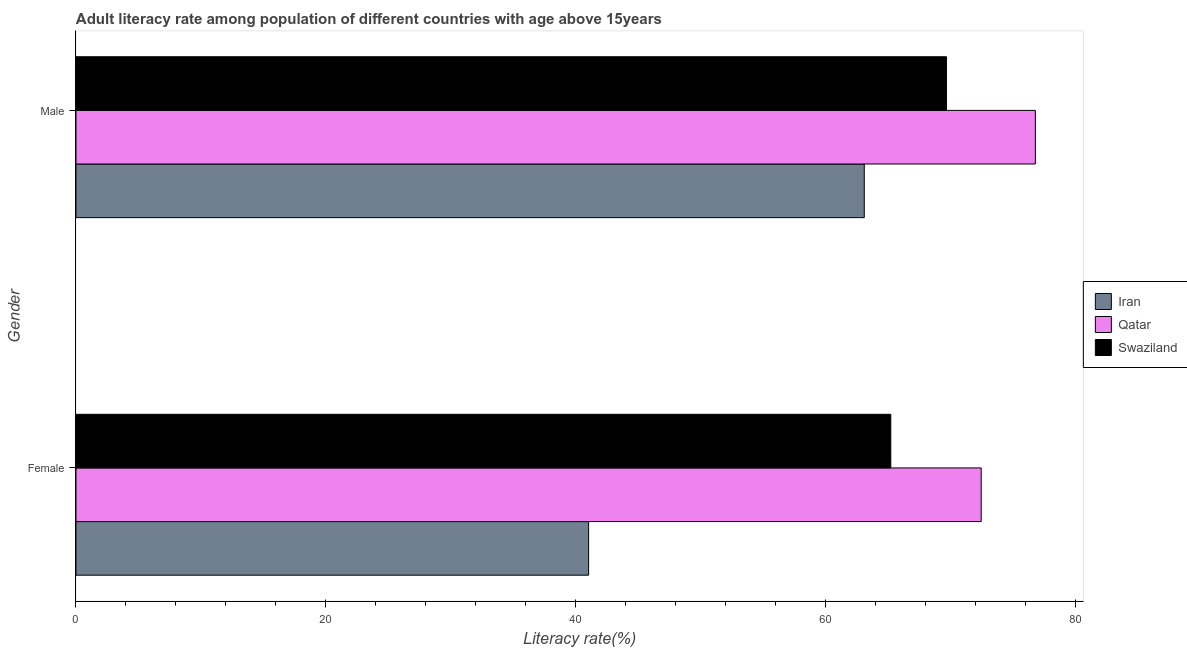How many bars are there on the 2nd tick from the top?
Make the answer very short. 3. What is the label of the 1st group of bars from the top?
Provide a succinct answer. Male. What is the female adult literacy rate in Qatar?
Offer a very short reply. 72.46. Across all countries, what is the maximum female adult literacy rate?
Your response must be concise. 72.46. Across all countries, what is the minimum male adult literacy rate?
Offer a terse response. 63.1. In which country was the female adult literacy rate maximum?
Your response must be concise. Qatar. In which country was the female adult literacy rate minimum?
Your answer should be very brief. Iran. What is the total male adult literacy rate in the graph?
Offer a very short reply. 209.58. What is the difference between the female adult literacy rate in Qatar and that in Iran?
Give a very brief answer. 31.43. What is the difference between the female adult literacy rate in Swaziland and the male adult literacy rate in Iran?
Give a very brief answer. 2.12. What is the average male adult literacy rate per country?
Offer a terse response. 69.86. What is the difference between the female adult literacy rate and male adult literacy rate in Iran?
Ensure brevity in your answer.  -22.07. In how many countries, is the male adult literacy rate greater than 60 %?
Keep it short and to the point. 3. What is the ratio of the female adult literacy rate in Iran to that in Swaziland?
Your answer should be very brief. 0.63. What does the 2nd bar from the top in Female represents?
Offer a very short reply. Qatar. What does the 2nd bar from the bottom in Female represents?
Your answer should be compact. Qatar. How many bars are there?
Your answer should be very brief. 6. Does the graph contain any zero values?
Provide a succinct answer. No. How are the legend labels stacked?
Make the answer very short. Vertical. What is the title of the graph?
Make the answer very short. Adult literacy rate among population of different countries with age above 15years. Does "Equatorial Guinea" appear as one of the legend labels in the graph?
Your answer should be compact. No. What is the label or title of the X-axis?
Offer a terse response. Literacy rate(%). What is the Literacy rate(%) of Iran in Female?
Offer a very short reply. 41.03. What is the Literacy rate(%) of Qatar in Female?
Your answer should be very brief. 72.46. What is the Literacy rate(%) of Swaziland in Female?
Offer a terse response. 65.22. What is the Literacy rate(%) of Iran in Male?
Give a very brief answer. 63.1. What is the Literacy rate(%) in Qatar in Male?
Make the answer very short. 76.8. What is the Literacy rate(%) of Swaziland in Male?
Give a very brief answer. 69.68. Across all Gender, what is the maximum Literacy rate(%) of Iran?
Ensure brevity in your answer.  63.1. Across all Gender, what is the maximum Literacy rate(%) in Qatar?
Your answer should be very brief. 76.8. Across all Gender, what is the maximum Literacy rate(%) in Swaziland?
Make the answer very short. 69.68. Across all Gender, what is the minimum Literacy rate(%) in Iran?
Provide a succinct answer. 41.03. Across all Gender, what is the minimum Literacy rate(%) of Qatar?
Ensure brevity in your answer.  72.46. Across all Gender, what is the minimum Literacy rate(%) of Swaziland?
Make the answer very short. 65.22. What is the total Literacy rate(%) of Iran in the graph?
Offer a very short reply. 104.13. What is the total Literacy rate(%) of Qatar in the graph?
Make the answer very short. 149.25. What is the total Literacy rate(%) of Swaziland in the graph?
Your response must be concise. 134.91. What is the difference between the Literacy rate(%) in Iran in Female and that in Male?
Ensure brevity in your answer.  -22.07. What is the difference between the Literacy rate(%) of Qatar in Female and that in Male?
Offer a very short reply. -4.34. What is the difference between the Literacy rate(%) of Swaziland in Female and that in Male?
Provide a short and direct response. -4.46. What is the difference between the Literacy rate(%) in Iran in Female and the Literacy rate(%) in Qatar in Male?
Offer a terse response. -35.76. What is the difference between the Literacy rate(%) of Iran in Female and the Literacy rate(%) of Swaziland in Male?
Keep it short and to the point. -28.65. What is the difference between the Literacy rate(%) in Qatar in Female and the Literacy rate(%) in Swaziland in Male?
Give a very brief answer. 2.78. What is the average Literacy rate(%) in Iran per Gender?
Give a very brief answer. 52.07. What is the average Literacy rate(%) of Qatar per Gender?
Give a very brief answer. 74.63. What is the average Literacy rate(%) in Swaziland per Gender?
Your response must be concise. 67.45. What is the difference between the Literacy rate(%) in Iran and Literacy rate(%) in Qatar in Female?
Your answer should be very brief. -31.43. What is the difference between the Literacy rate(%) in Iran and Literacy rate(%) in Swaziland in Female?
Provide a succinct answer. -24.19. What is the difference between the Literacy rate(%) in Qatar and Literacy rate(%) in Swaziland in Female?
Ensure brevity in your answer.  7.24. What is the difference between the Literacy rate(%) of Iran and Literacy rate(%) of Qatar in Male?
Offer a very short reply. -13.7. What is the difference between the Literacy rate(%) in Iran and Literacy rate(%) in Swaziland in Male?
Your answer should be compact. -6.58. What is the difference between the Literacy rate(%) in Qatar and Literacy rate(%) in Swaziland in Male?
Offer a terse response. 7.11. What is the ratio of the Literacy rate(%) of Iran in Female to that in Male?
Provide a succinct answer. 0.65. What is the ratio of the Literacy rate(%) of Qatar in Female to that in Male?
Offer a very short reply. 0.94. What is the ratio of the Literacy rate(%) of Swaziland in Female to that in Male?
Offer a very short reply. 0.94. What is the difference between the highest and the second highest Literacy rate(%) of Iran?
Keep it short and to the point. 22.07. What is the difference between the highest and the second highest Literacy rate(%) of Qatar?
Your answer should be compact. 4.34. What is the difference between the highest and the second highest Literacy rate(%) of Swaziland?
Offer a very short reply. 4.46. What is the difference between the highest and the lowest Literacy rate(%) of Iran?
Ensure brevity in your answer.  22.07. What is the difference between the highest and the lowest Literacy rate(%) of Qatar?
Give a very brief answer. 4.34. What is the difference between the highest and the lowest Literacy rate(%) of Swaziland?
Give a very brief answer. 4.46. 